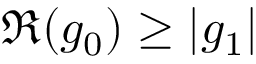<formula> <loc_0><loc_0><loc_500><loc_500>\Re ( g _ { 0 } ) \geq | g _ { 1 } |</formula> 